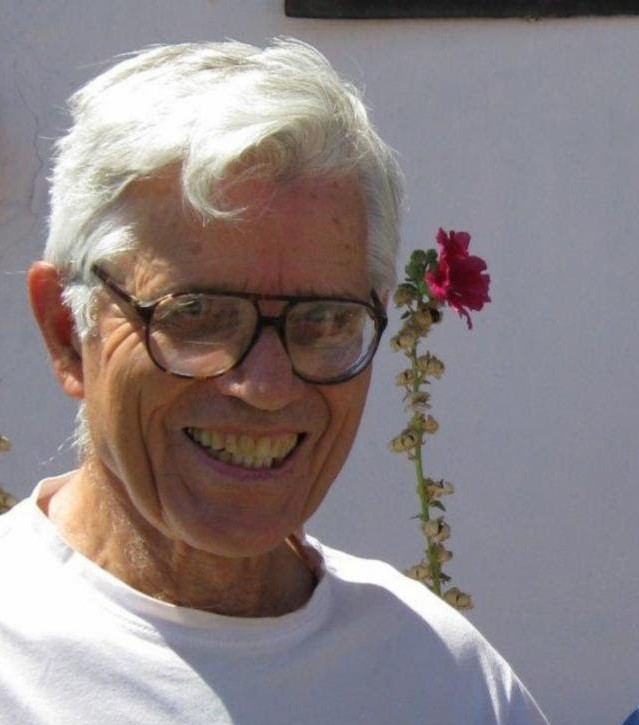Imagine a story that involves the man and the flower. One day, an elderly man named George was tending to his beautiful garden, a source of pride and joy for him. As he was pruning the roses, he noticed a vibrant red carnation standing out among the flower beds. Amused by its striking color and vibrancy, he decided to pluck it and playfully place it atop his head. George then spotted his old friend, Martha, walking towards him. He greeted her with a broad smile, and they laughed together at the sight of the flower perched on his head. They spent the afternoon reminiscing about their younger days, surrounded by the serene atmosphere of the garden. The carnation remained a symbol of their enduring friendship and a testament to finding joy in simple, playful moments. 